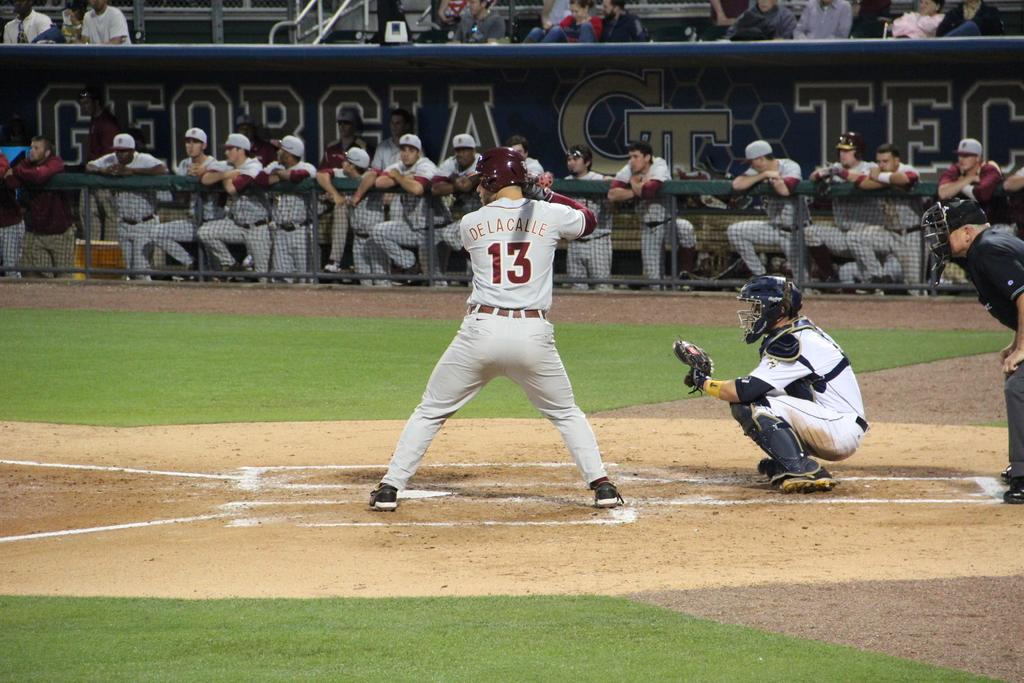Provide a one-sentence caption for the provided image. Man in a number 13 jersey getting ready to bat at plate. 